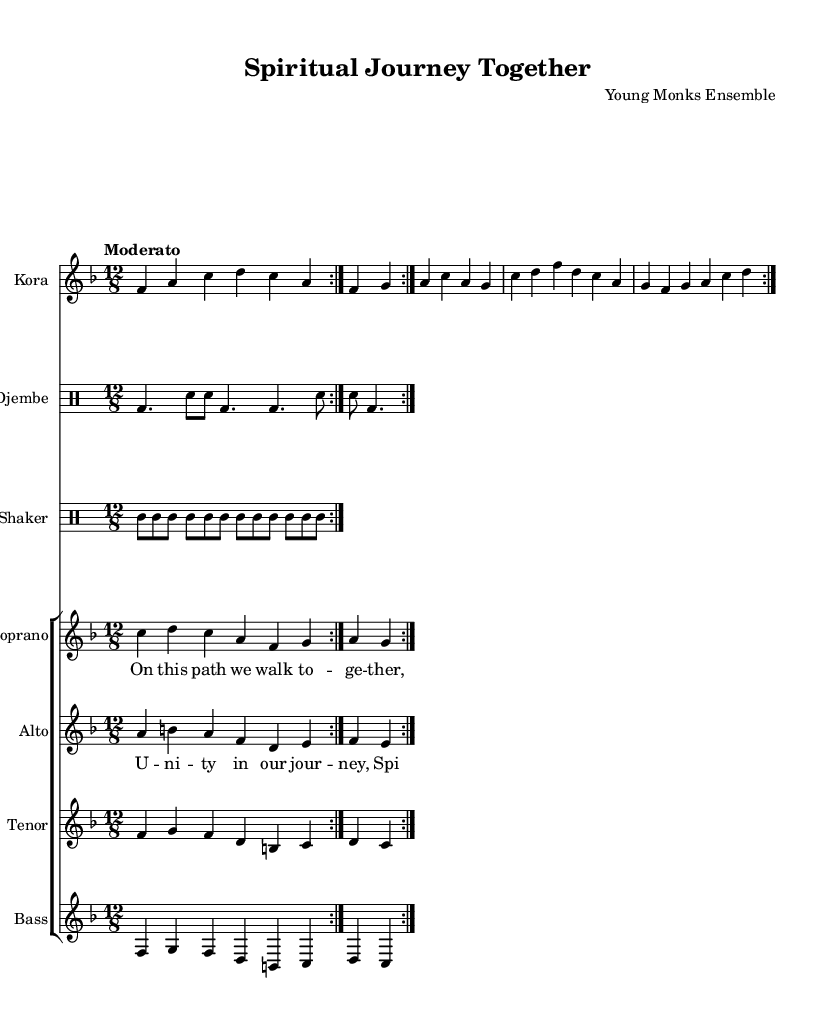What is the key signature of this music? The key signature is F major, which has one flat (B♭). This can be identified by looking at the key signature at the beginning of the staff.
Answer: F major What is the time signature of this music? The time signature is 12/8, indicated at the start of the score. This means there are 12 eighth-note beats in each measure.
Answer: 12/8 What is the tempo marking? The tempo marking is "Moderato," which is indicated above the staff. This suggests a moderate speed for the piece.
Answer: Moderato How many measures are repeated in the kora music? The kora music section has 2 measures that are repeated, as indicated by the repeat signs (volta).
Answer: 2 What is the lyrical theme of the chorus? The lyrical theme celebrates the notion of unity and spiritual growth during the journey together. This is clear from the lyrics provided, which emphasize unity and spirits shining bright.
Answer: Unity Which instrument accompanies the vocals in the composition? The Kora provides the main accompaniment alongside the Djembe and Shaker, which provide rhythmic support. This can be inferred from the instrumentation provided in the score.
Answer: Kora How many vocal parts are present in the choir section? There are four vocal parts: Soprano, Alto, Tenor, and Bass. This is evident from the separate staves indicated for each voice type within the choir section.
Answer: 4 